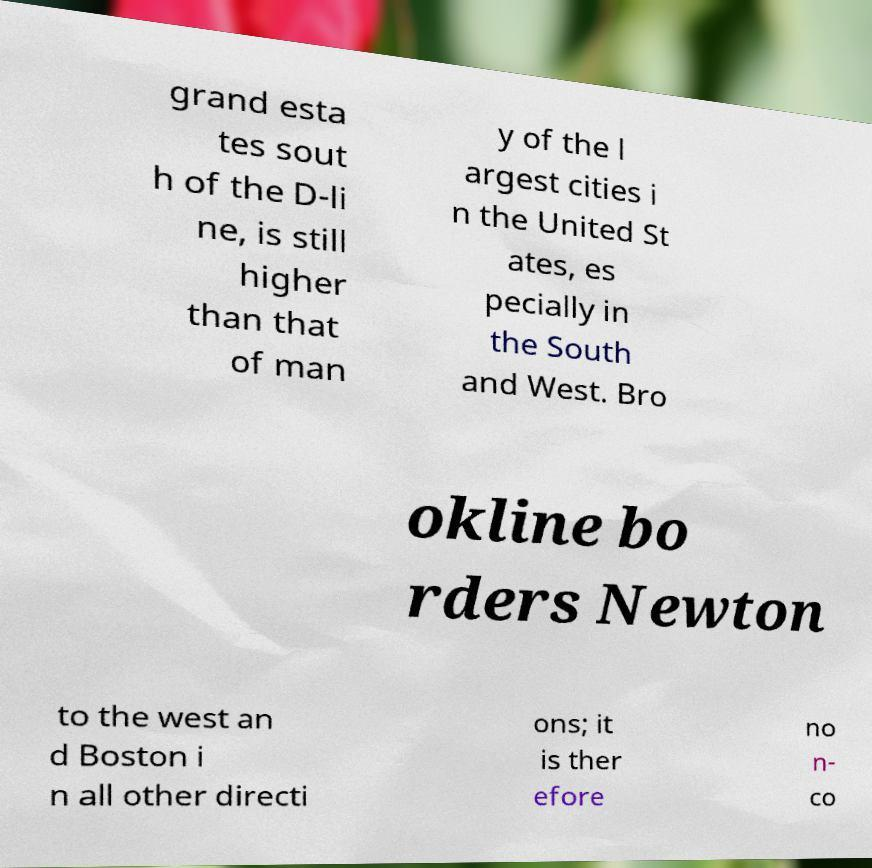There's text embedded in this image that I need extracted. Can you transcribe it verbatim? grand esta tes sout h of the D-li ne, is still higher than that of man y of the l argest cities i n the United St ates, es pecially in the South and West. Bro okline bo rders Newton to the west an d Boston i n all other directi ons; it is ther efore no n- co 